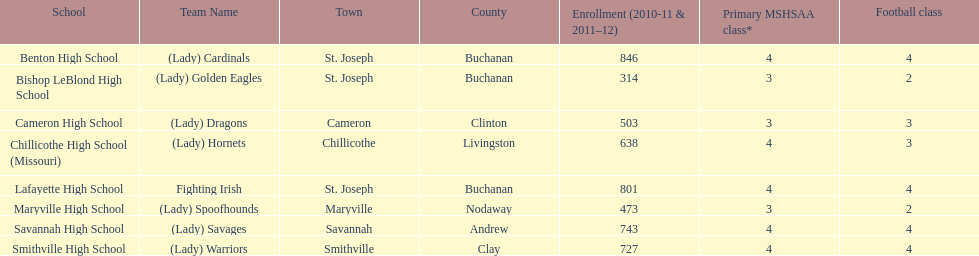Are green and grey the colors of lafayette high school or benton high school? Lafayette High School. 